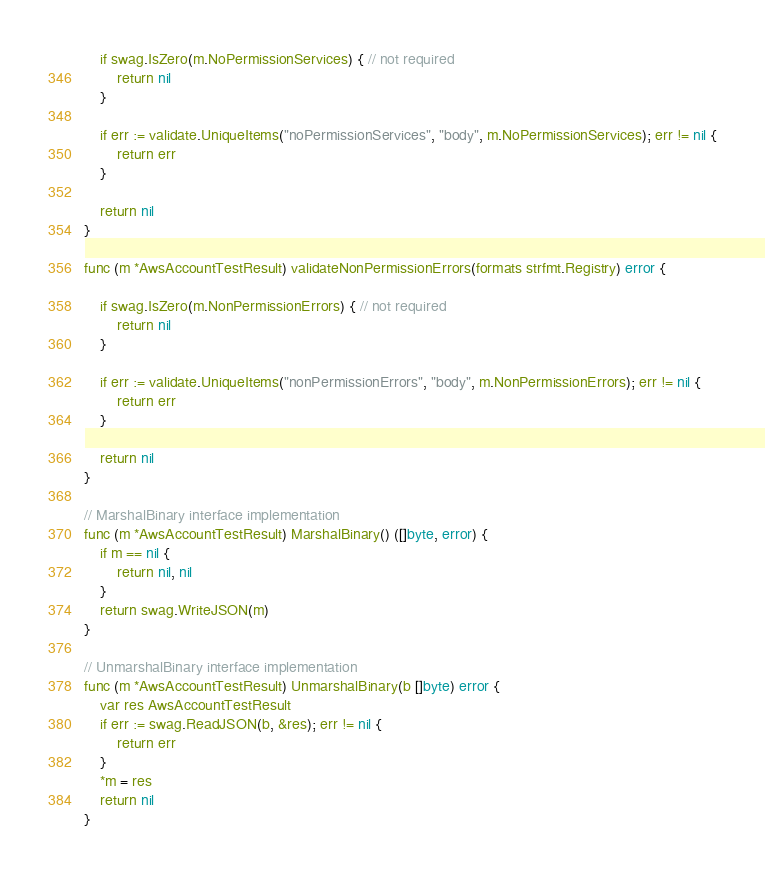<code> <loc_0><loc_0><loc_500><loc_500><_Go_>
	if swag.IsZero(m.NoPermissionServices) { // not required
		return nil
	}

	if err := validate.UniqueItems("noPermissionServices", "body", m.NoPermissionServices); err != nil {
		return err
	}

	return nil
}

func (m *AwsAccountTestResult) validateNonPermissionErrors(formats strfmt.Registry) error {

	if swag.IsZero(m.NonPermissionErrors) { // not required
		return nil
	}

	if err := validate.UniqueItems("nonPermissionErrors", "body", m.NonPermissionErrors); err != nil {
		return err
	}

	return nil
}

// MarshalBinary interface implementation
func (m *AwsAccountTestResult) MarshalBinary() ([]byte, error) {
	if m == nil {
		return nil, nil
	}
	return swag.WriteJSON(m)
}

// UnmarshalBinary interface implementation
func (m *AwsAccountTestResult) UnmarshalBinary(b []byte) error {
	var res AwsAccountTestResult
	if err := swag.ReadJSON(b, &res); err != nil {
		return err
	}
	*m = res
	return nil
}
</code> 